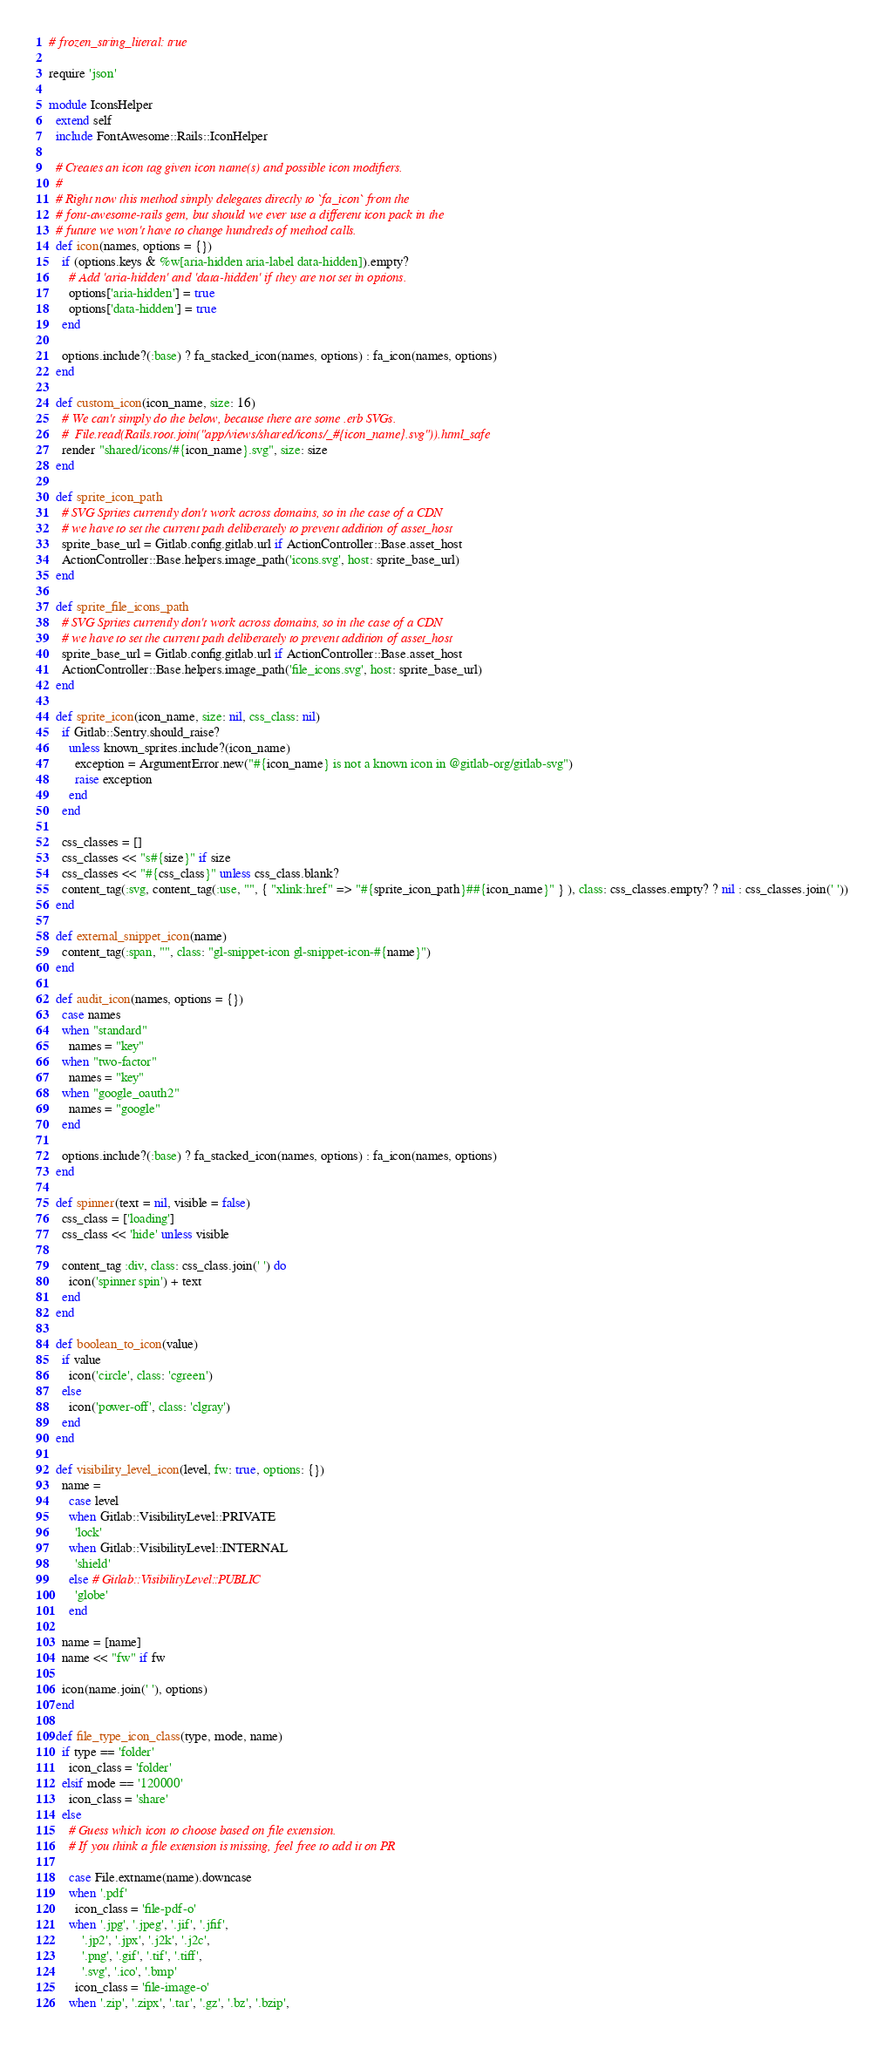Convert code to text. <code><loc_0><loc_0><loc_500><loc_500><_Ruby_># frozen_string_literal: true

require 'json'

module IconsHelper
  extend self
  include FontAwesome::Rails::IconHelper

  # Creates an icon tag given icon name(s) and possible icon modifiers.
  #
  # Right now this method simply delegates directly to `fa_icon` from the
  # font-awesome-rails gem, but should we ever use a different icon pack in the
  # future we won't have to change hundreds of method calls.
  def icon(names, options = {})
    if (options.keys & %w[aria-hidden aria-label data-hidden]).empty?
      # Add 'aria-hidden' and 'data-hidden' if they are not set in options.
      options['aria-hidden'] = true
      options['data-hidden'] = true
    end

    options.include?(:base) ? fa_stacked_icon(names, options) : fa_icon(names, options)
  end

  def custom_icon(icon_name, size: 16)
    # We can't simply do the below, because there are some .erb SVGs.
    #  File.read(Rails.root.join("app/views/shared/icons/_#{icon_name}.svg")).html_safe
    render "shared/icons/#{icon_name}.svg", size: size
  end

  def sprite_icon_path
    # SVG Sprites currently don't work across domains, so in the case of a CDN
    # we have to set the current path deliberately to prevent addition of asset_host
    sprite_base_url = Gitlab.config.gitlab.url if ActionController::Base.asset_host
    ActionController::Base.helpers.image_path('icons.svg', host: sprite_base_url)
  end

  def sprite_file_icons_path
    # SVG Sprites currently don't work across domains, so in the case of a CDN
    # we have to set the current path deliberately to prevent addition of asset_host
    sprite_base_url = Gitlab.config.gitlab.url if ActionController::Base.asset_host
    ActionController::Base.helpers.image_path('file_icons.svg', host: sprite_base_url)
  end

  def sprite_icon(icon_name, size: nil, css_class: nil)
    if Gitlab::Sentry.should_raise?
      unless known_sprites.include?(icon_name)
        exception = ArgumentError.new("#{icon_name} is not a known icon in @gitlab-org/gitlab-svg")
        raise exception
      end
    end

    css_classes = []
    css_classes << "s#{size}" if size
    css_classes << "#{css_class}" unless css_class.blank?
    content_tag(:svg, content_tag(:use, "", { "xlink:href" => "#{sprite_icon_path}##{icon_name}" } ), class: css_classes.empty? ? nil : css_classes.join(' '))
  end

  def external_snippet_icon(name)
    content_tag(:span, "", class: "gl-snippet-icon gl-snippet-icon-#{name}")
  end

  def audit_icon(names, options = {})
    case names
    when "standard"
      names = "key"
    when "two-factor"
      names = "key"
    when "google_oauth2"
      names = "google"
    end

    options.include?(:base) ? fa_stacked_icon(names, options) : fa_icon(names, options)
  end

  def spinner(text = nil, visible = false)
    css_class = ['loading']
    css_class << 'hide' unless visible

    content_tag :div, class: css_class.join(' ') do
      icon('spinner spin') + text
    end
  end

  def boolean_to_icon(value)
    if value
      icon('circle', class: 'cgreen')
    else
      icon('power-off', class: 'clgray')
    end
  end

  def visibility_level_icon(level, fw: true, options: {})
    name =
      case level
      when Gitlab::VisibilityLevel::PRIVATE
        'lock'
      when Gitlab::VisibilityLevel::INTERNAL
        'shield'
      else # Gitlab::VisibilityLevel::PUBLIC
        'globe'
      end

    name = [name]
    name << "fw" if fw

    icon(name.join(' '), options)
  end

  def file_type_icon_class(type, mode, name)
    if type == 'folder'
      icon_class = 'folder'
    elsif mode == '120000'
      icon_class = 'share'
    else
      # Guess which icon to choose based on file extension.
      # If you think a file extension is missing, feel free to add it on PR

      case File.extname(name).downcase
      when '.pdf'
        icon_class = 'file-pdf-o'
      when '.jpg', '.jpeg', '.jif', '.jfif',
          '.jp2', '.jpx', '.j2k', '.j2c',
          '.png', '.gif', '.tif', '.tiff',
          '.svg', '.ico', '.bmp'
        icon_class = 'file-image-o'
      when '.zip', '.zipx', '.tar', '.gz', '.bz', '.bzip',</code> 